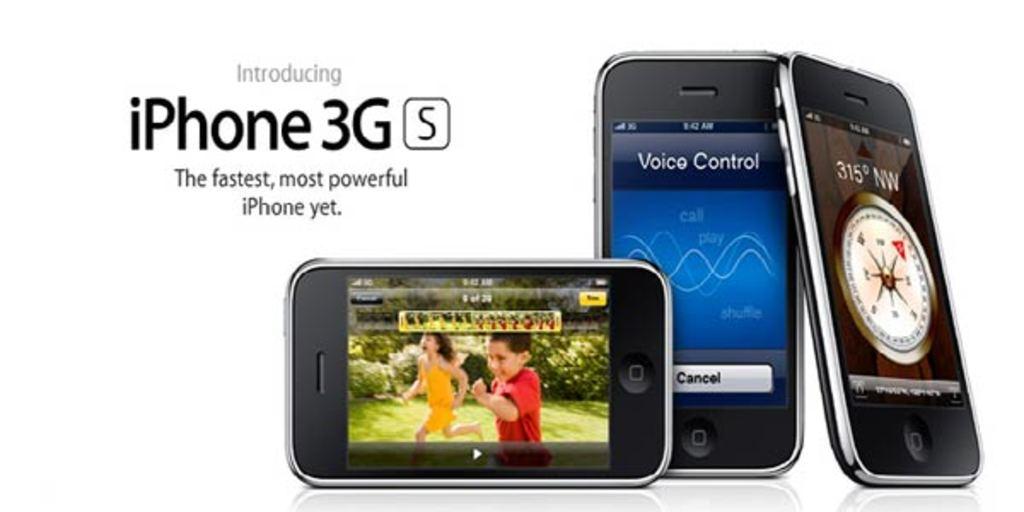What brand of phone is on the box?
Your response must be concise. Iphone. What is written on the middle phone's screen?
Provide a succinct answer. Voice control. 